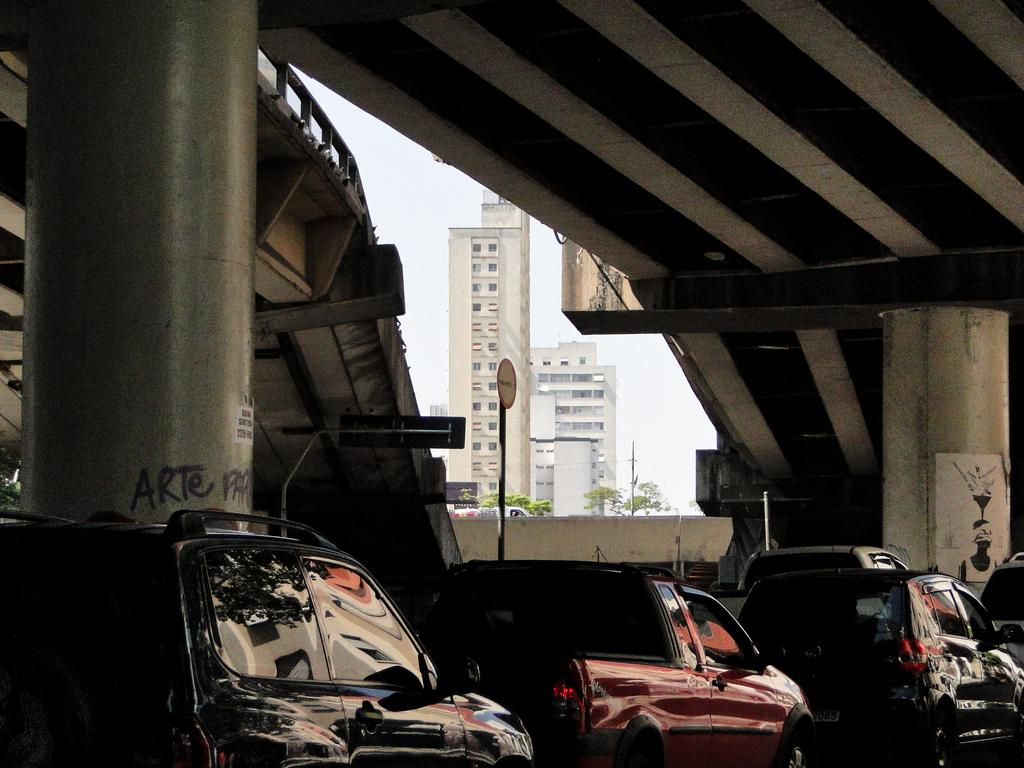Where was the image taken from? The image was taken at the bottom side of a flyover. What can be seen supporting the flyover in the image? The pillars of the flyover are visible in the image. What are the parked vehicles in the image? Cars are parked in the image. What structure is located in the center of the image? There is a building in the center of the image. What is the chance of winning the lottery in the image? There is no information about the lottery or winning chances in the image. What account is being settled in the image? There is no mention of any accounts or financial transactions in the image. 